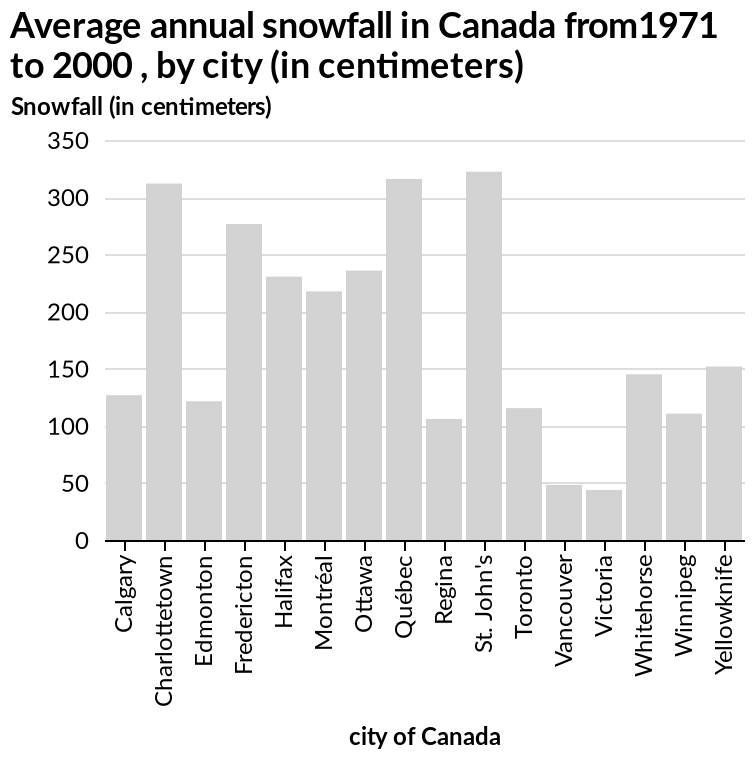<image>
What is the subject of the bar chart?  The subject of the bar chart is the average annual snowfall in Canada. Which city in Canada has the lowest annual snowfall?  Victoria has the lowest annual snowfall in Canada. How much snowfall does Vancouver receive annually? Vancouver receives below 50cm of snow per year. What city in Canada has the highest annual snowfall?  St. John's has the highest annual snowfall in Canada. 